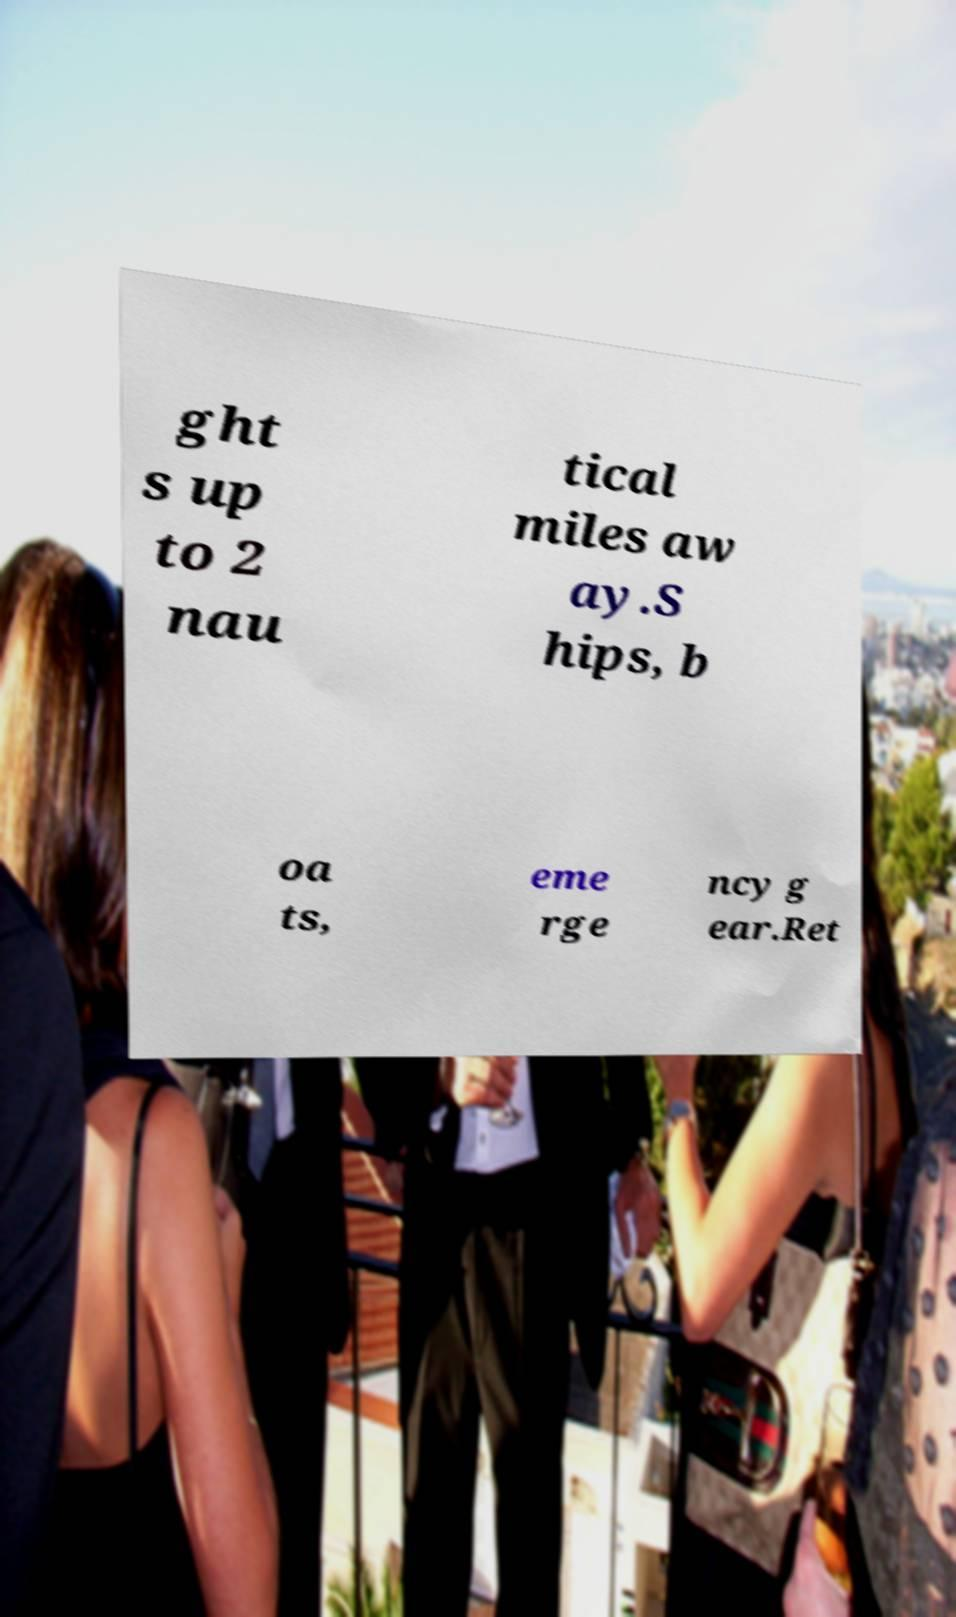Can you accurately transcribe the text from the provided image for me? ght s up to 2 nau tical miles aw ay.S hips, b oa ts, eme rge ncy g ear.Ret 